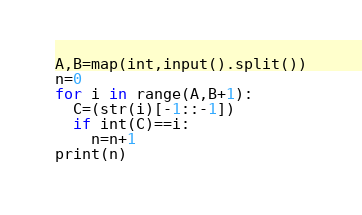<code> <loc_0><loc_0><loc_500><loc_500><_Python_>A,B=map(int,input().split())
n=0
for i in range(A,B+1):
  C=(str(i)[-1::-1])
  if int(C)==i:
    n=n+1
print(n)</code> 